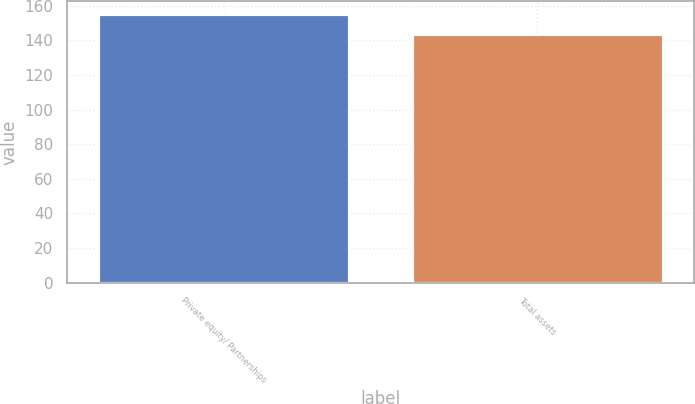Convert chart to OTSL. <chart><loc_0><loc_0><loc_500><loc_500><bar_chart><fcel>Private equity/ Partnerships<fcel>Total assets<nl><fcel>155<fcel>144<nl></chart> 